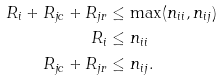Convert formula to latex. <formula><loc_0><loc_0><loc_500><loc_500>R _ { i } + R _ { j c } + R _ { j r } & \leq \max ( n _ { i i } , n _ { i j } ) \\ R _ { i } & \leq n _ { i i } \\ R _ { j c } + R _ { j r } & \leq n _ { i j } .</formula> 